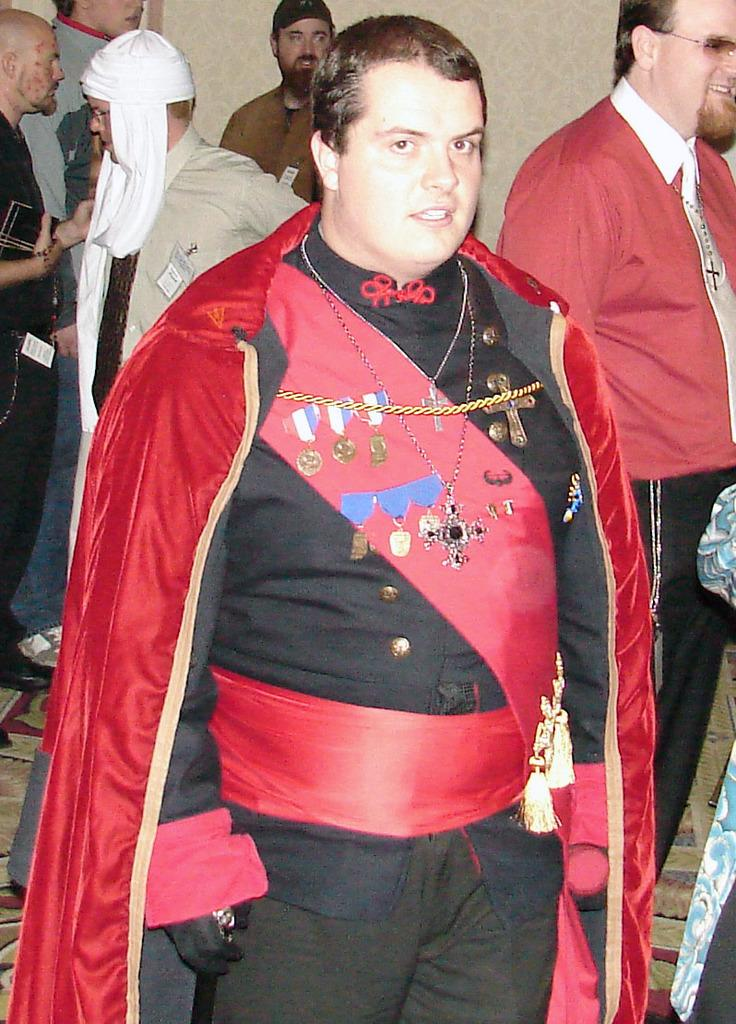Who is the main subject in the image? There is a man in the center of the image. What is the man wearing in the image? The man appears to be wearing a costume. Can you describe the background of the image? There are other people in the background of the image. What type of bead is the man holding in the image? There is no bead visible in the image; the man is wearing a costume. How does the man use the brake in the image? There is no brake present in the image; it is a man wearing a costume. 